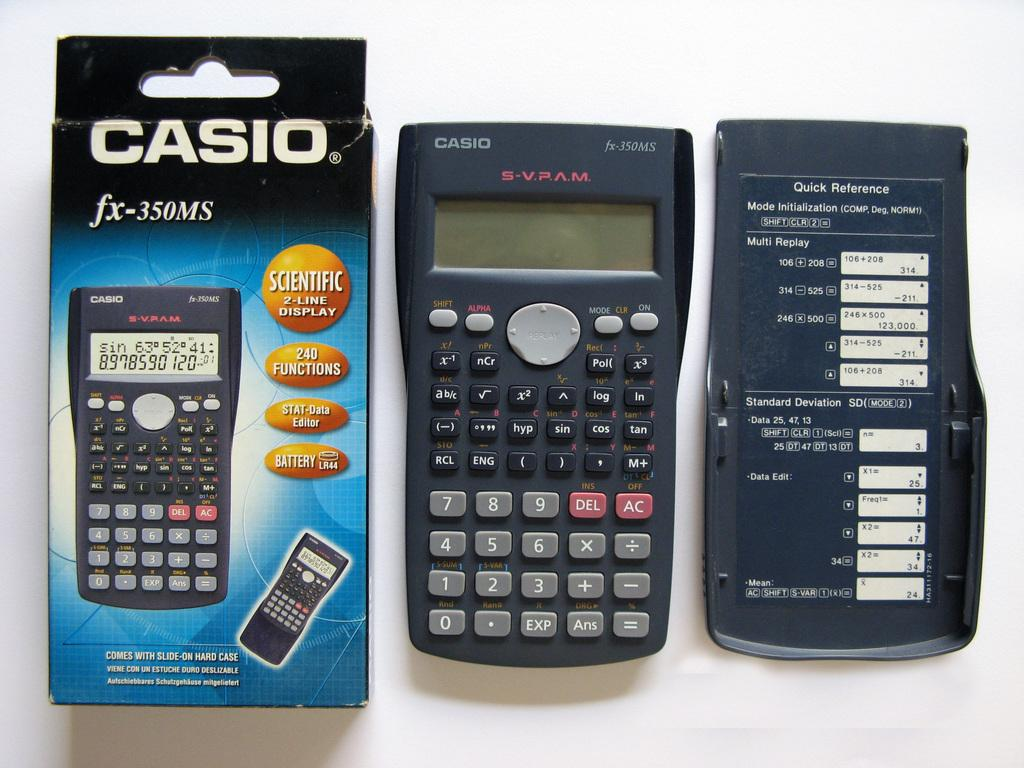What type of device is present in the image? There is a calculator in the image. What other items related to the calculator can be seen in the image? There is a calculator back cover and a calculator box in the image. Where is the frog sitting on the calculator in the image? There is no frog present in the image. What type of plants can be seen growing around the calculator in the image? There are no plants visible in the image. Is the calculator located on an island in the image? There is no island present in the image. 